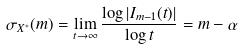<formula> <loc_0><loc_0><loc_500><loc_500>\sigma _ { X ^ { * } } ( m ) = \lim _ { t \to \infty } \frac { \log \left | I _ { m - 1 } ( t ) \right | } { \log t } = m - \alpha</formula> 